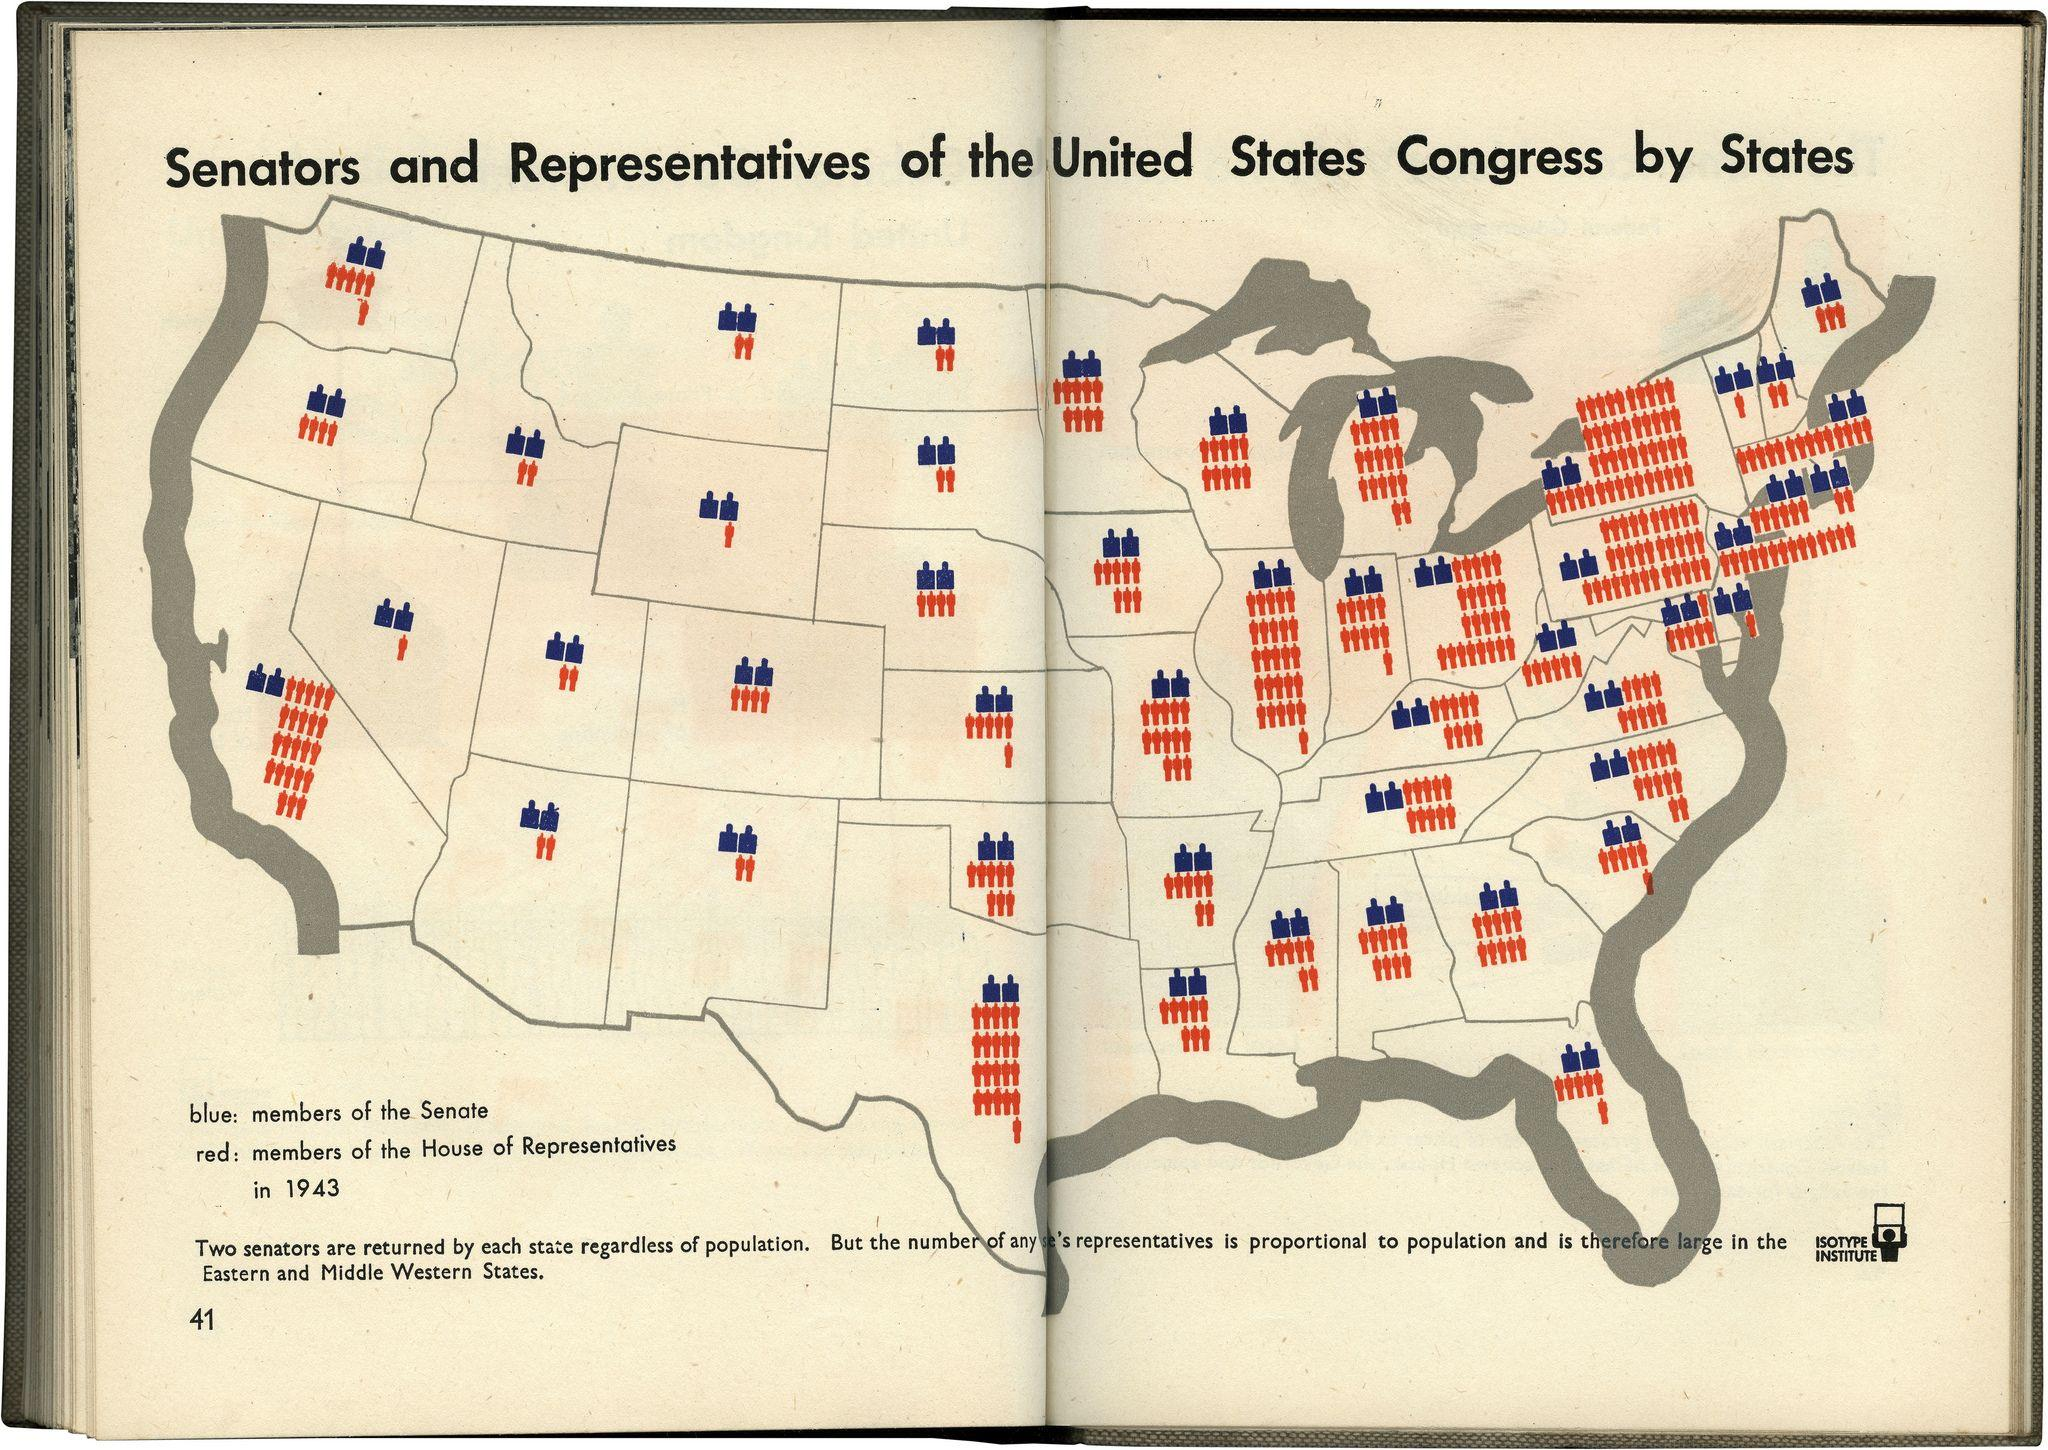Identify some key points in this picture. The population is lower in the Western region of the United States compared to the Eastern region. 